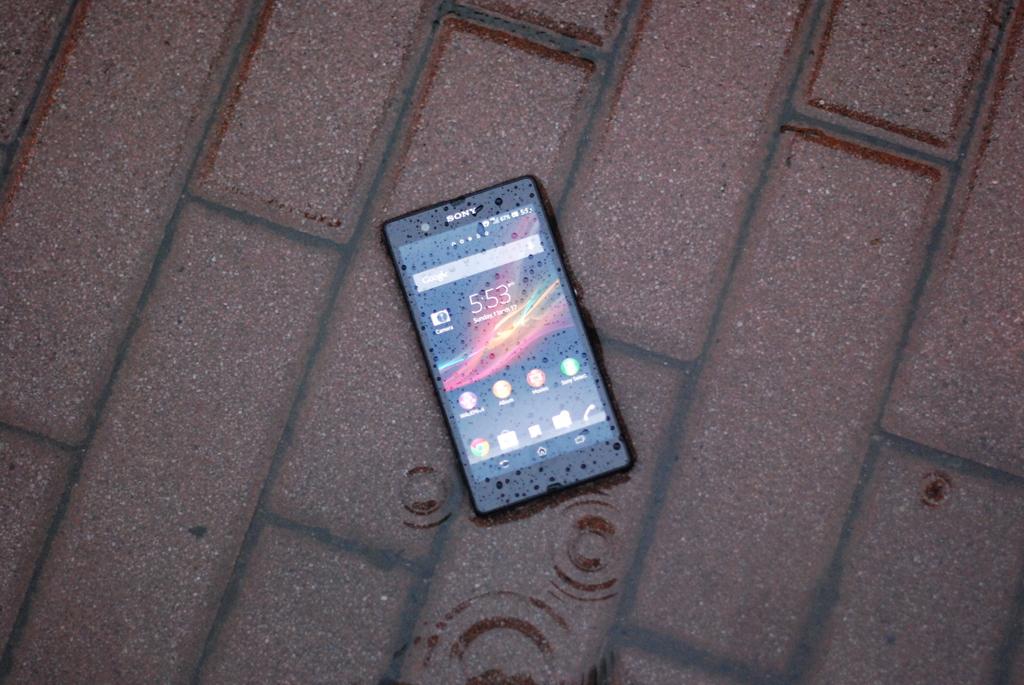What time is it?
Your answer should be very brief. 5:53. What brand phone?
Ensure brevity in your answer.  Sony. 